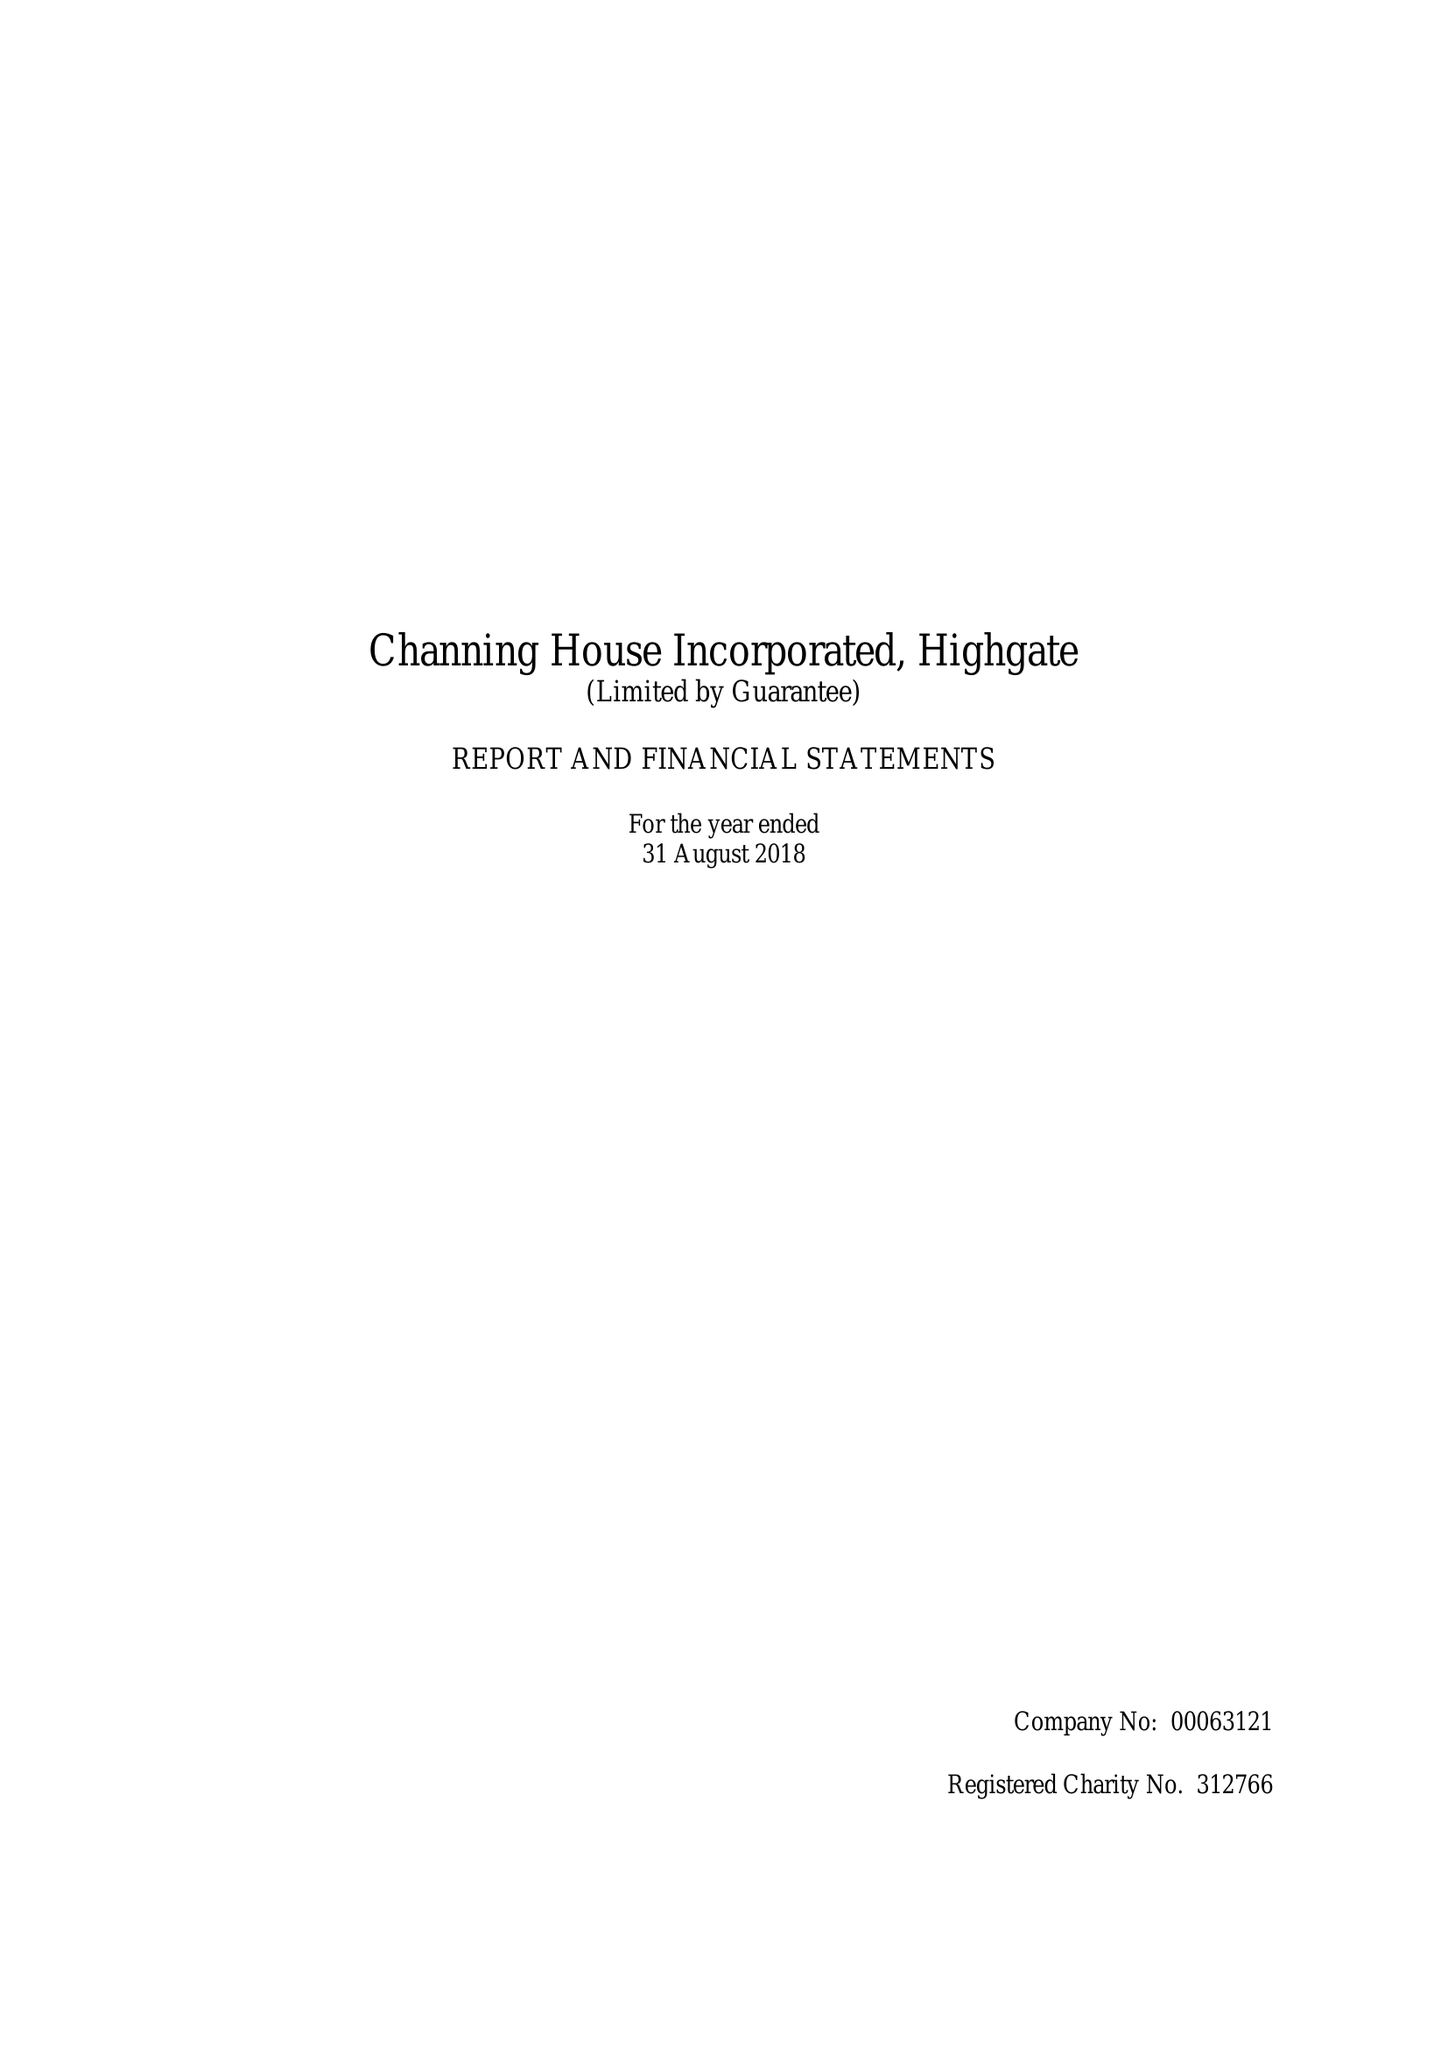What is the value for the spending_annually_in_british_pounds?
Answer the question using a single word or phrase. 15331700.00 